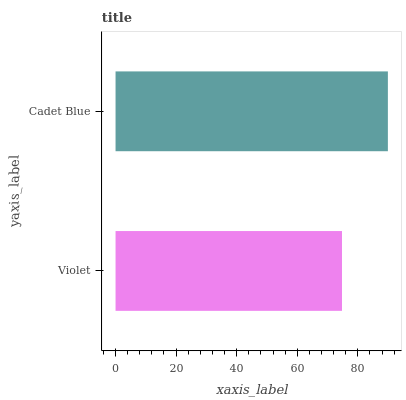Is Violet the minimum?
Answer yes or no. Yes. Is Cadet Blue the maximum?
Answer yes or no. Yes. Is Cadet Blue the minimum?
Answer yes or no. No. Is Cadet Blue greater than Violet?
Answer yes or no. Yes. Is Violet less than Cadet Blue?
Answer yes or no. Yes. Is Violet greater than Cadet Blue?
Answer yes or no. No. Is Cadet Blue less than Violet?
Answer yes or no. No. Is Cadet Blue the high median?
Answer yes or no. Yes. Is Violet the low median?
Answer yes or no. Yes. Is Violet the high median?
Answer yes or no. No. Is Cadet Blue the low median?
Answer yes or no. No. 